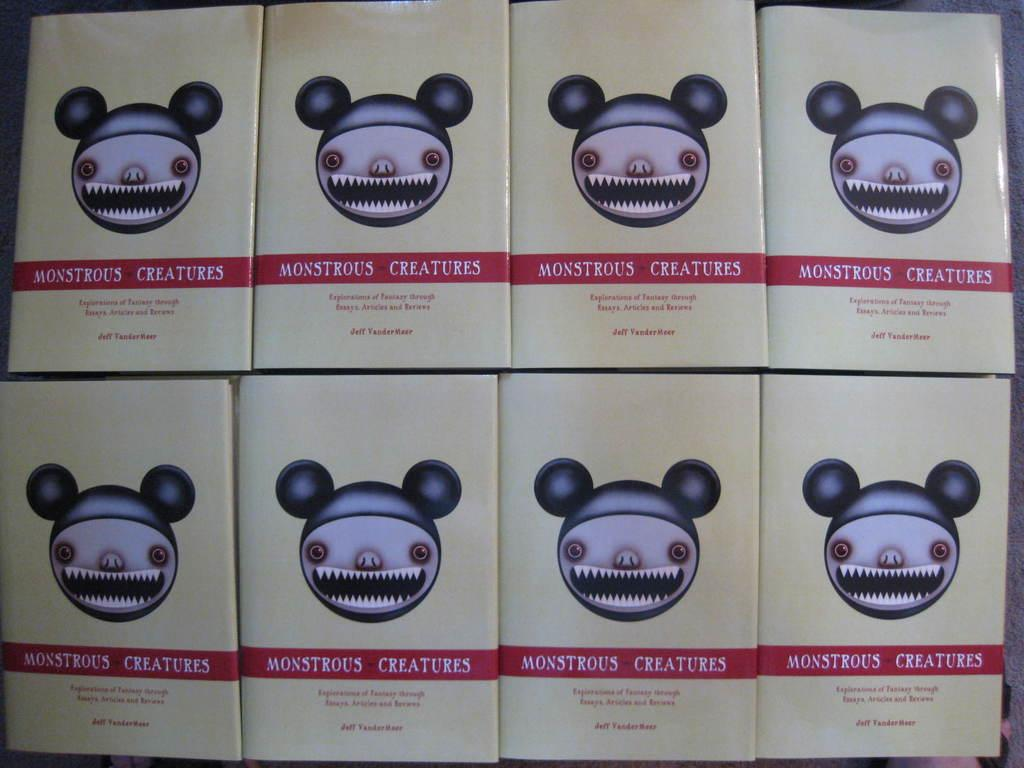How many books are visible in the image? There are eight books in the image. What is depicted on each book? Each book has a monster drawn on it. Is there any text present on the books? Yes, there is text written on each book. What type of oatmeal is being served in the lunchroom depicted in the image? There is no lunchroom or oatmeal present in the image; it features eight books with monsters drawn on them and text written on them. 